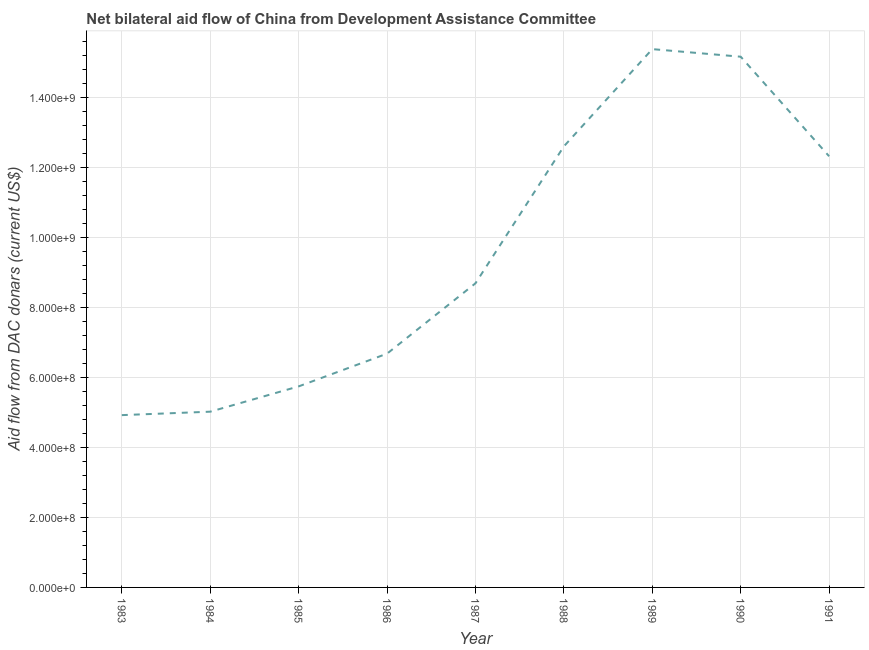What is the net bilateral aid flows from dac donors in 1989?
Keep it short and to the point. 1.54e+09. Across all years, what is the maximum net bilateral aid flows from dac donors?
Your answer should be compact. 1.54e+09. Across all years, what is the minimum net bilateral aid flows from dac donors?
Your response must be concise. 4.92e+08. In which year was the net bilateral aid flows from dac donors maximum?
Offer a very short reply. 1989. What is the sum of the net bilateral aid flows from dac donors?
Provide a short and direct response. 8.66e+09. What is the difference between the net bilateral aid flows from dac donors in 1985 and 1989?
Keep it short and to the point. -9.64e+08. What is the average net bilateral aid flows from dac donors per year?
Give a very brief answer. 9.62e+08. What is the median net bilateral aid flows from dac donors?
Offer a terse response. 8.69e+08. In how many years, is the net bilateral aid flows from dac donors greater than 1160000000 US$?
Give a very brief answer. 4. What is the ratio of the net bilateral aid flows from dac donors in 1983 to that in 1988?
Ensure brevity in your answer.  0.39. Is the net bilateral aid flows from dac donors in 1984 less than that in 1986?
Provide a succinct answer. Yes. Is the difference between the net bilateral aid flows from dac donors in 1988 and 1990 greater than the difference between any two years?
Offer a very short reply. No. What is the difference between the highest and the second highest net bilateral aid flows from dac donors?
Provide a succinct answer. 2.17e+07. What is the difference between the highest and the lowest net bilateral aid flows from dac donors?
Offer a terse response. 1.05e+09. In how many years, is the net bilateral aid flows from dac donors greater than the average net bilateral aid flows from dac donors taken over all years?
Provide a short and direct response. 4. How many lines are there?
Offer a very short reply. 1. What is the difference between two consecutive major ticks on the Y-axis?
Offer a very short reply. 2.00e+08. Does the graph contain any zero values?
Your answer should be compact. No. What is the title of the graph?
Provide a short and direct response. Net bilateral aid flow of China from Development Assistance Committee. What is the label or title of the X-axis?
Offer a very short reply. Year. What is the label or title of the Y-axis?
Keep it short and to the point. Aid flow from DAC donars (current US$). What is the Aid flow from DAC donars (current US$) of 1983?
Offer a very short reply. 4.92e+08. What is the Aid flow from DAC donars (current US$) of 1984?
Your response must be concise. 5.02e+08. What is the Aid flow from DAC donars (current US$) of 1985?
Your answer should be very brief. 5.75e+08. What is the Aid flow from DAC donars (current US$) of 1986?
Provide a short and direct response. 6.68e+08. What is the Aid flow from DAC donars (current US$) in 1987?
Your answer should be compact. 8.69e+08. What is the Aid flow from DAC donars (current US$) in 1988?
Keep it short and to the point. 1.26e+09. What is the Aid flow from DAC donars (current US$) in 1989?
Ensure brevity in your answer.  1.54e+09. What is the Aid flow from DAC donars (current US$) of 1990?
Provide a short and direct response. 1.52e+09. What is the Aid flow from DAC donars (current US$) in 1991?
Your response must be concise. 1.23e+09. What is the difference between the Aid flow from DAC donars (current US$) in 1983 and 1984?
Your answer should be very brief. -9.83e+06. What is the difference between the Aid flow from DAC donars (current US$) in 1983 and 1985?
Offer a very short reply. -8.21e+07. What is the difference between the Aid flow from DAC donars (current US$) in 1983 and 1986?
Ensure brevity in your answer.  -1.76e+08. What is the difference between the Aid flow from DAC donars (current US$) in 1983 and 1987?
Offer a terse response. -3.77e+08. What is the difference between the Aid flow from DAC donars (current US$) in 1983 and 1988?
Make the answer very short. -7.68e+08. What is the difference between the Aid flow from DAC donars (current US$) in 1983 and 1989?
Ensure brevity in your answer.  -1.05e+09. What is the difference between the Aid flow from DAC donars (current US$) in 1983 and 1990?
Provide a short and direct response. -1.02e+09. What is the difference between the Aid flow from DAC donars (current US$) in 1983 and 1991?
Provide a short and direct response. -7.40e+08. What is the difference between the Aid flow from DAC donars (current US$) in 1984 and 1985?
Give a very brief answer. -7.23e+07. What is the difference between the Aid flow from DAC donars (current US$) in 1984 and 1986?
Provide a succinct answer. -1.66e+08. What is the difference between the Aid flow from DAC donars (current US$) in 1984 and 1987?
Ensure brevity in your answer.  -3.67e+08. What is the difference between the Aid flow from DAC donars (current US$) in 1984 and 1988?
Your answer should be very brief. -7.58e+08. What is the difference between the Aid flow from DAC donars (current US$) in 1984 and 1989?
Keep it short and to the point. -1.04e+09. What is the difference between the Aid flow from DAC donars (current US$) in 1984 and 1990?
Give a very brief answer. -1.01e+09. What is the difference between the Aid flow from DAC donars (current US$) in 1984 and 1991?
Your answer should be very brief. -7.30e+08. What is the difference between the Aid flow from DAC donars (current US$) in 1985 and 1986?
Offer a terse response. -9.36e+07. What is the difference between the Aid flow from DAC donars (current US$) in 1985 and 1987?
Offer a terse response. -2.95e+08. What is the difference between the Aid flow from DAC donars (current US$) in 1985 and 1988?
Your answer should be compact. -6.86e+08. What is the difference between the Aid flow from DAC donars (current US$) in 1985 and 1989?
Your answer should be compact. -9.64e+08. What is the difference between the Aid flow from DAC donars (current US$) in 1985 and 1990?
Your answer should be compact. -9.42e+08. What is the difference between the Aid flow from DAC donars (current US$) in 1985 and 1991?
Provide a short and direct response. -6.58e+08. What is the difference between the Aid flow from DAC donars (current US$) in 1986 and 1987?
Make the answer very short. -2.01e+08. What is the difference between the Aid flow from DAC donars (current US$) in 1986 and 1988?
Provide a succinct answer. -5.93e+08. What is the difference between the Aid flow from DAC donars (current US$) in 1986 and 1989?
Your answer should be very brief. -8.70e+08. What is the difference between the Aid flow from DAC donars (current US$) in 1986 and 1990?
Ensure brevity in your answer.  -8.49e+08. What is the difference between the Aid flow from DAC donars (current US$) in 1986 and 1991?
Provide a short and direct response. -5.64e+08. What is the difference between the Aid flow from DAC donars (current US$) in 1987 and 1988?
Your answer should be compact. -3.91e+08. What is the difference between the Aid flow from DAC donars (current US$) in 1987 and 1989?
Make the answer very short. -6.69e+08. What is the difference between the Aid flow from DAC donars (current US$) in 1987 and 1990?
Ensure brevity in your answer.  -6.48e+08. What is the difference between the Aid flow from DAC donars (current US$) in 1987 and 1991?
Make the answer very short. -3.63e+08. What is the difference between the Aid flow from DAC donars (current US$) in 1988 and 1989?
Your response must be concise. -2.78e+08. What is the difference between the Aid flow from DAC donars (current US$) in 1988 and 1990?
Your response must be concise. -2.56e+08. What is the difference between the Aid flow from DAC donars (current US$) in 1988 and 1991?
Your response must be concise. 2.84e+07. What is the difference between the Aid flow from DAC donars (current US$) in 1989 and 1990?
Your answer should be very brief. 2.17e+07. What is the difference between the Aid flow from DAC donars (current US$) in 1989 and 1991?
Your response must be concise. 3.06e+08. What is the difference between the Aid flow from DAC donars (current US$) in 1990 and 1991?
Your answer should be very brief. 2.85e+08. What is the ratio of the Aid flow from DAC donars (current US$) in 1983 to that in 1985?
Ensure brevity in your answer.  0.86. What is the ratio of the Aid flow from DAC donars (current US$) in 1983 to that in 1986?
Your answer should be very brief. 0.74. What is the ratio of the Aid flow from DAC donars (current US$) in 1983 to that in 1987?
Offer a terse response. 0.57. What is the ratio of the Aid flow from DAC donars (current US$) in 1983 to that in 1988?
Provide a succinct answer. 0.39. What is the ratio of the Aid flow from DAC donars (current US$) in 1983 to that in 1989?
Make the answer very short. 0.32. What is the ratio of the Aid flow from DAC donars (current US$) in 1983 to that in 1990?
Provide a succinct answer. 0.33. What is the ratio of the Aid flow from DAC donars (current US$) in 1983 to that in 1991?
Provide a succinct answer. 0.4. What is the ratio of the Aid flow from DAC donars (current US$) in 1984 to that in 1985?
Offer a very short reply. 0.87. What is the ratio of the Aid flow from DAC donars (current US$) in 1984 to that in 1986?
Keep it short and to the point. 0.75. What is the ratio of the Aid flow from DAC donars (current US$) in 1984 to that in 1987?
Make the answer very short. 0.58. What is the ratio of the Aid flow from DAC donars (current US$) in 1984 to that in 1988?
Offer a terse response. 0.4. What is the ratio of the Aid flow from DAC donars (current US$) in 1984 to that in 1989?
Ensure brevity in your answer.  0.33. What is the ratio of the Aid flow from DAC donars (current US$) in 1984 to that in 1990?
Ensure brevity in your answer.  0.33. What is the ratio of the Aid flow from DAC donars (current US$) in 1984 to that in 1991?
Provide a short and direct response. 0.41. What is the ratio of the Aid flow from DAC donars (current US$) in 1985 to that in 1986?
Provide a short and direct response. 0.86. What is the ratio of the Aid flow from DAC donars (current US$) in 1985 to that in 1987?
Offer a terse response. 0.66. What is the ratio of the Aid flow from DAC donars (current US$) in 1985 to that in 1988?
Ensure brevity in your answer.  0.46. What is the ratio of the Aid flow from DAC donars (current US$) in 1985 to that in 1989?
Offer a terse response. 0.37. What is the ratio of the Aid flow from DAC donars (current US$) in 1985 to that in 1990?
Keep it short and to the point. 0.38. What is the ratio of the Aid flow from DAC donars (current US$) in 1985 to that in 1991?
Provide a succinct answer. 0.47. What is the ratio of the Aid flow from DAC donars (current US$) in 1986 to that in 1987?
Provide a short and direct response. 0.77. What is the ratio of the Aid flow from DAC donars (current US$) in 1986 to that in 1988?
Keep it short and to the point. 0.53. What is the ratio of the Aid flow from DAC donars (current US$) in 1986 to that in 1989?
Your answer should be compact. 0.43. What is the ratio of the Aid flow from DAC donars (current US$) in 1986 to that in 1990?
Provide a succinct answer. 0.44. What is the ratio of the Aid flow from DAC donars (current US$) in 1986 to that in 1991?
Provide a short and direct response. 0.54. What is the ratio of the Aid flow from DAC donars (current US$) in 1987 to that in 1988?
Give a very brief answer. 0.69. What is the ratio of the Aid flow from DAC donars (current US$) in 1987 to that in 1989?
Your response must be concise. 0.56. What is the ratio of the Aid flow from DAC donars (current US$) in 1987 to that in 1990?
Provide a short and direct response. 0.57. What is the ratio of the Aid flow from DAC donars (current US$) in 1987 to that in 1991?
Provide a short and direct response. 0.7. What is the ratio of the Aid flow from DAC donars (current US$) in 1988 to that in 1989?
Offer a terse response. 0.82. What is the ratio of the Aid flow from DAC donars (current US$) in 1988 to that in 1990?
Your answer should be very brief. 0.83. What is the ratio of the Aid flow from DAC donars (current US$) in 1988 to that in 1991?
Keep it short and to the point. 1.02. What is the ratio of the Aid flow from DAC donars (current US$) in 1989 to that in 1990?
Your response must be concise. 1.01. What is the ratio of the Aid flow from DAC donars (current US$) in 1989 to that in 1991?
Ensure brevity in your answer.  1.25. What is the ratio of the Aid flow from DAC donars (current US$) in 1990 to that in 1991?
Offer a very short reply. 1.23. 